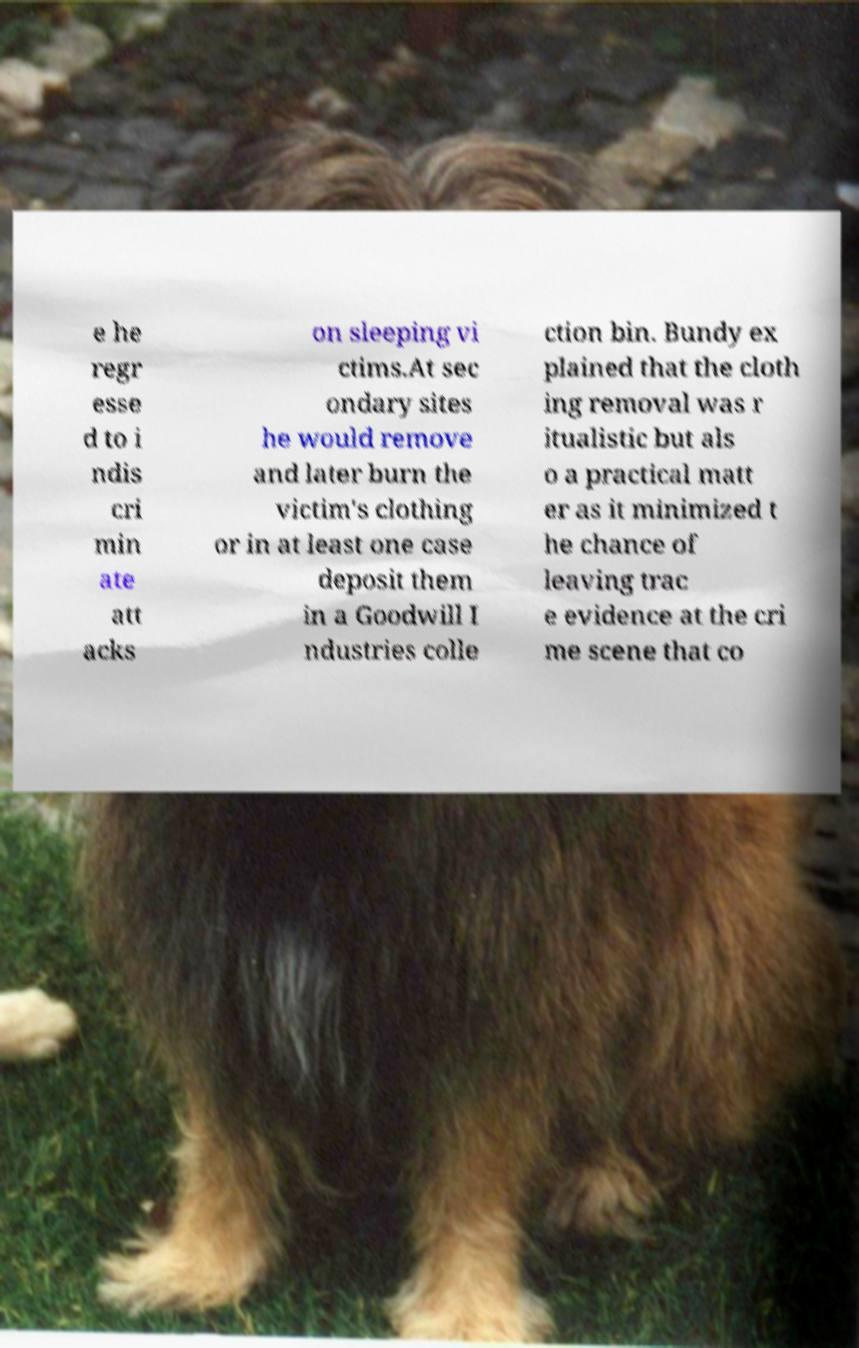Can you read and provide the text displayed in the image?This photo seems to have some interesting text. Can you extract and type it out for me? e he regr esse d to i ndis cri min ate att acks on sleeping vi ctims.At sec ondary sites he would remove and later burn the victim's clothing or in at least one case deposit them in a Goodwill I ndustries colle ction bin. Bundy ex plained that the cloth ing removal was r itualistic but als o a practical matt er as it minimized t he chance of leaving trac e evidence at the cri me scene that co 